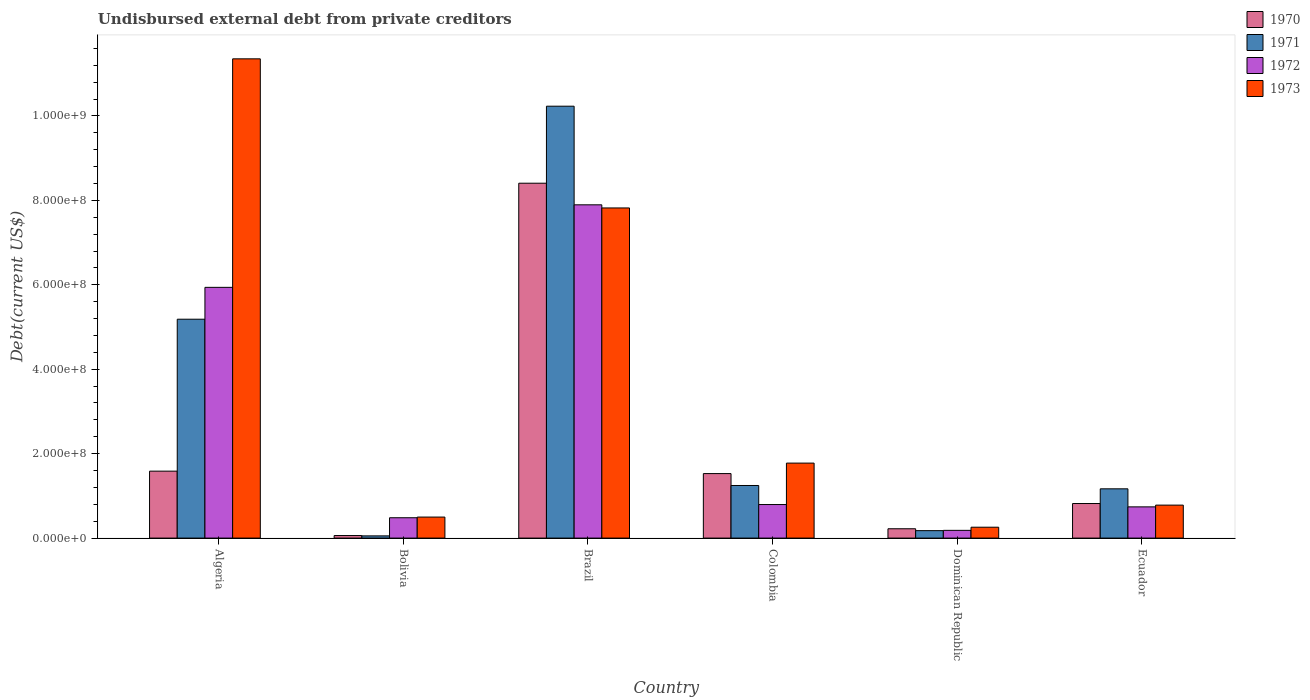How many different coloured bars are there?
Offer a terse response. 4. Are the number of bars on each tick of the X-axis equal?
Your response must be concise. Yes. What is the label of the 3rd group of bars from the left?
Keep it short and to the point. Brazil. In how many cases, is the number of bars for a given country not equal to the number of legend labels?
Give a very brief answer. 0. What is the total debt in 1973 in Algeria?
Provide a succinct answer. 1.14e+09. Across all countries, what is the maximum total debt in 1970?
Provide a succinct answer. 8.41e+08. Across all countries, what is the minimum total debt in 1970?
Your answer should be compact. 6.05e+06. In which country was the total debt in 1972 maximum?
Offer a terse response. Brazil. What is the total total debt in 1971 in the graph?
Give a very brief answer. 1.81e+09. What is the difference between the total debt in 1971 in Colombia and that in Dominican Republic?
Offer a very short reply. 1.07e+08. What is the difference between the total debt in 1973 in Algeria and the total debt in 1970 in Ecuador?
Ensure brevity in your answer.  1.05e+09. What is the average total debt in 1973 per country?
Ensure brevity in your answer.  3.75e+08. What is the difference between the total debt of/in 1973 and total debt of/in 1971 in Colombia?
Keep it short and to the point. 5.30e+07. What is the ratio of the total debt in 1972 in Algeria to that in Bolivia?
Make the answer very short. 12.32. Is the total debt in 1973 in Dominican Republic less than that in Ecuador?
Your response must be concise. Yes. What is the difference between the highest and the second highest total debt in 1973?
Your response must be concise. 9.58e+08. What is the difference between the highest and the lowest total debt in 1972?
Offer a very short reply. 7.71e+08. Is it the case that in every country, the sum of the total debt in 1972 and total debt in 1971 is greater than the sum of total debt in 1973 and total debt in 1970?
Ensure brevity in your answer.  No. What does the 4th bar from the right in Colombia represents?
Offer a very short reply. 1970. How many bars are there?
Ensure brevity in your answer.  24. Are all the bars in the graph horizontal?
Keep it short and to the point. No. Where does the legend appear in the graph?
Offer a terse response. Top right. How are the legend labels stacked?
Give a very brief answer. Vertical. What is the title of the graph?
Give a very brief answer. Undisbursed external debt from private creditors. What is the label or title of the Y-axis?
Give a very brief answer. Debt(current US$). What is the Debt(current US$) of 1970 in Algeria?
Provide a succinct answer. 1.59e+08. What is the Debt(current US$) of 1971 in Algeria?
Give a very brief answer. 5.18e+08. What is the Debt(current US$) of 1972 in Algeria?
Provide a succinct answer. 5.94e+08. What is the Debt(current US$) in 1973 in Algeria?
Offer a terse response. 1.14e+09. What is the Debt(current US$) in 1970 in Bolivia?
Your answer should be compact. 6.05e+06. What is the Debt(current US$) in 1971 in Bolivia?
Ensure brevity in your answer.  5.25e+06. What is the Debt(current US$) of 1972 in Bolivia?
Give a very brief answer. 4.82e+07. What is the Debt(current US$) of 1973 in Bolivia?
Give a very brief answer. 4.98e+07. What is the Debt(current US$) in 1970 in Brazil?
Make the answer very short. 8.41e+08. What is the Debt(current US$) of 1971 in Brazil?
Offer a very short reply. 1.02e+09. What is the Debt(current US$) in 1972 in Brazil?
Keep it short and to the point. 7.89e+08. What is the Debt(current US$) in 1973 in Brazil?
Offer a terse response. 7.82e+08. What is the Debt(current US$) of 1970 in Colombia?
Keep it short and to the point. 1.53e+08. What is the Debt(current US$) in 1971 in Colombia?
Your response must be concise. 1.25e+08. What is the Debt(current US$) of 1972 in Colombia?
Keep it short and to the point. 7.95e+07. What is the Debt(current US$) in 1973 in Colombia?
Ensure brevity in your answer.  1.78e+08. What is the Debt(current US$) in 1970 in Dominican Republic?
Keep it short and to the point. 2.21e+07. What is the Debt(current US$) of 1971 in Dominican Republic?
Your answer should be very brief. 1.76e+07. What is the Debt(current US$) in 1972 in Dominican Republic?
Keep it short and to the point. 1.83e+07. What is the Debt(current US$) of 1973 in Dominican Republic?
Give a very brief answer. 2.58e+07. What is the Debt(current US$) in 1970 in Ecuador?
Offer a terse response. 8.19e+07. What is the Debt(current US$) in 1971 in Ecuador?
Your answer should be compact. 1.17e+08. What is the Debt(current US$) in 1972 in Ecuador?
Provide a succinct answer. 7.40e+07. What is the Debt(current US$) in 1973 in Ecuador?
Offer a very short reply. 7.81e+07. Across all countries, what is the maximum Debt(current US$) in 1970?
Your answer should be very brief. 8.41e+08. Across all countries, what is the maximum Debt(current US$) in 1971?
Your answer should be very brief. 1.02e+09. Across all countries, what is the maximum Debt(current US$) of 1972?
Offer a very short reply. 7.89e+08. Across all countries, what is the maximum Debt(current US$) in 1973?
Provide a short and direct response. 1.14e+09. Across all countries, what is the minimum Debt(current US$) of 1970?
Your answer should be very brief. 6.05e+06. Across all countries, what is the minimum Debt(current US$) in 1971?
Make the answer very short. 5.25e+06. Across all countries, what is the minimum Debt(current US$) in 1972?
Give a very brief answer. 1.83e+07. Across all countries, what is the minimum Debt(current US$) of 1973?
Make the answer very short. 2.58e+07. What is the total Debt(current US$) in 1970 in the graph?
Keep it short and to the point. 1.26e+09. What is the total Debt(current US$) of 1971 in the graph?
Offer a terse response. 1.81e+09. What is the total Debt(current US$) of 1972 in the graph?
Your answer should be very brief. 1.60e+09. What is the total Debt(current US$) in 1973 in the graph?
Your answer should be very brief. 2.25e+09. What is the difference between the Debt(current US$) of 1970 in Algeria and that in Bolivia?
Your answer should be compact. 1.53e+08. What is the difference between the Debt(current US$) of 1971 in Algeria and that in Bolivia?
Offer a terse response. 5.13e+08. What is the difference between the Debt(current US$) in 1972 in Algeria and that in Bolivia?
Make the answer very short. 5.46e+08. What is the difference between the Debt(current US$) of 1973 in Algeria and that in Bolivia?
Make the answer very short. 1.09e+09. What is the difference between the Debt(current US$) in 1970 in Algeria and that in Brazil?
Ensure brevity in your answer.  -6.82e+08. What is the difference between the Debt(current US$) of 1971 in Algeria and that in Brazil?
Offer a terse response. -5.05e+08. What is the difference between the Debt(current US$) of 1972 in Algeria and that in Brazil?
Keep it short and to the point. -1.95e+08. What is the difference between the Debt(current US$) in 1973 in Algeria and that in Brazil?
Give a very brief answer. 3.53e+08. What is the difference between the Debt(current US$) of 1970 in Algeria and that in Colombia?
Offer a terse response. 5.77e+06. What is the difference between the Debt(current US$) of 1971 in Algeria and that in Colombia?
Offer a terse response. 3.94e+08. What is the difference between the Debt(current US$) in 1972 in Algeria and that in Colombia?
Ensure brevity in your answer.  5.14e+08. What is the difference between the Debt(current US$) in 1973 in Algeria and that in Colombia?
Your answer should be very brief. 9.58e+08. What is the difference between the Debt(current US$) in 1970 in Algeria and that in Dominican Republic?
Ensure brevity in your answer.  1.36e+08. What is the difference between the Debt(current US$) in 1971 in Algeria and that in Dominican Republic?
Your answer should be compact. 5.01e+08. What is the difference between the Debt(current US$) of 1972 in Algeria and that in Dominican Republic?
Offer a terse response. 5.76e+08. What is the difference between the Debt(current US$) of 1973 in Algeria and that in Dominican Republic?
Your response must be concise. 1.11e+09. What is the difference between the Debt(current US$) in 1970 in Algeria and that in Ecuador?
Provide a succinct answer. 7.67e+07. What is the difference between the Debt(current US$) in 1971 in Algeria and that in Ecuador?
Offer a very short reply. 4.02e+08. What is the difference between the Debt(current US$) in 1972 in Algeria and that in Ecuador?
Offer a very short reply. 5.20e+08. What is the difference between the Debt(current US$) of 1973 in Algeria and that in Ecuador?
Provide a short and direct response. 1.06e+09. What is the difference between the Debt(current US$) of 1970 in Bolivia and that in Brazil?
Provide a succinct answer. -8.35e+08. What is the difference between the Debt(current US$) in 1971 in Bolivia and that in Brazil?
Keep it short and to the point. -1.02e+09. What is the difference between the Debt(current US$) in 1972 in Bolivia and that in Brazil?
Offer a very short reply. -7.41e+08. What is the difference between the Debt(current US$) in 1973 in Bolivia and that in Brazil?
Provide a succinct answer. -7.32e+08. What is the difference between the Debt(current US$) of 1970 in Bolivia and that in Colombia?
Provide a succinct answer. -1.47e+08. What is the difference between the Debt(current US$) of 1971 in Bolivia and that in Colombia?
Provide a short and direct response. -1.19e+08. What is the difference between the Debt(current US$) in 1972 in Bolivia and that in Colombia?
Offer a very short reply. -3.13e+07. What is the difference between the Debt(current US$) in 1973 in Bolivia and that in Colombia?
Give a very brief answer. -1.28e+08. What is the difference between the Debt(current US$) of 1970 in Bolivia and that in Dominican Republic?
Provide a succinct answer. -1.60e+07. What is the difference between the Debt(current US$) of 1971 in Bolivia and that in Dominican Republic?
Offer a very short reply. -1.24e+07. What is the difference between the Debt(current US$) in 1972 in Bolivia and that in Dominican Republic?
Your answer should be compact. 2.99e+07. What is the difference between the Debt(current US$) of 1973 in Bolivia and that in Dominican Republic?
Provide a succinct answer. 2.40e+07. What is the difference between the Debt(current US$) of 1970 in Bolivia and that in Ecuador?
Make the answer very short. -7.58e+07. What is the difference between the Debt(current US$) in 1971 in Bolivia and that in Ecuador?
Provide a short and direct response. -1.11e+08. What is the difference between the Debt(current US$) of 1972 in Bolivia and that in Ecuador?
Your answer should be compact. -2.58e+07. What is the difference between the Debt(current US$) in 1973 in Bolivia and that in Ecuador?
Offer a terse response. -2.83e+07. What is the difference between the Debt(current US$) of 1970 in Brazil and that in Colombia?
Give a very brief answer. 6.88e+08. What is the difference between the Debt(current US$) in 1971 in Brazil and that in Colombia?
Give a very brief answer. 8.98e+08. What is the difference between the Debt(current US$) in 1972 in Brazil and that in Colombia?
Your answer should be very brief. 7.10e+08. What is the difference between the Debt(current US$) of 1973 in Brazil and that in Colombia?
Offer a very short reply. 6.04e+08. What is the difference between the Debt(current US$) of 1970 in Brazil and that in Dominican Republic?
Your answer should be very brief. 8.19e+08. What is the difference between the Debt(current US$) of 1971 in Brazil and that in Dominican Republic?
Offer a very short reply. 1.01e+09. What is the difference between the Debt(current US$) in 1972 in Brazil and that in Dominican Republic?
Make the answer very short. 7.71e+08. What is the difference between the Debt(current US$) in 1973 in Brazil and that in Dominican Republic?
Provide a succinct answer. 7.56e+08. What is the difference between the Debt(current US$) in 1970 in Brazil and that in Ecuador?
Provide a short and direct response. 7.59e+08. What is the difference between the Debt(current US$) in 1971 in Brazil and that in Ecuador?
Your answer should be compact. 9.06e+08. What is the difference between the Debt(current US$) in 1972 in Brazil and that in Ecuador?
Provide a short and direct response. 7.15e+08. What is the difference between the Debt(current US$) of 1973 in Brazil and that in Ecuador?
Provide a succinct answer. 7.04e+08. What is the difference between the Debt(current US$) of 1970 in Colombia and that in Dominican Republic?
Make the answer very short. 1.31e+08. What is the difference between the Debt(current US$) of 1971 in Colombia and that in Dominican Republic?
Make the answer very short. 1.07e+08. What is the difference between the Debt(current US$) of 1972 in Colombia and that in Dominican Republic?
Offer a terse response. 6.12e+07. What is the difference between the Debt(current US$) of 1973 in Colombia and that in Dominican Republic?
Your response must be concise. 1.52e+08. What is the difference between the Debt(current US$) in 1970 in Colombia and that in Ecuador?
Your response must be concise. 7.09e+07. What is the difference between the Debt(current US$) in 1971 in Colombia and that in Ecuador?
Offer a very short reply. 7.88e+06. What is the difference between the Debt(current US$) in 1972 in Colombia and that in Ecuador?
Your answer should be very brief. 5.49e+06. What is the difference between the Debt(current US$) of 1973 in Colombia and that in Ecuador?
Offer a very short reply. 9.95e+07. What is the difference between the Debt(current US$) of 1970 in Dominican Republic and that in Ecuador?
Offer a very short reply. -5.98e+07. What is the difference between the Debt(current US$) of 1971 in Dominican Republic and that in Ecuador?
Your answer should be very brief. -9.91e+07. What is the difference between the Debt(current US$) in 1972 in Dominican Republic and that in Ecuador?
Offer a terse response. -5.57e+07. What is the difference between the Debt(current US$) of 1973 in Dominican Republic and that in Ecuador?
Offer a terse response. -5.23e+07. What is the difference between the Debt(current US$) of 1970 in Algeria and the Debt(current US$) of 1971 in Bolivia?
Your answer should be very brief. 1.53e+08. What is the difference between the Debt(current US$) of 1970 in Algeria and the Debt(current US$) of 1972 in Bolivia?
Provide a short and direct response. 1.10e+08. What is the difference between the Debt(current US$) of 1970 in Algeria and the Debt(current US$) of 1973 in Bolivia?
Offer a terse response. 1.09e+08. What is the difference between the Debt(current US$) of 1971 in Algeria and the Debt(current US$) of 1972 in Bolivia?
Your response must be concise. 4.70e+08. What is the difference between the Debt(current US$) of 1971 in Algeria and the Debt(current US$) of 1973 in Bolivia?
Your answer should be compact. 4.69e+08. What is the difference between the Debt(current US$) of 1972 in Algeria and the Debt(current US$) of 1973 in Bolivia?
Your answer should be very brief. 5.44e+08. What is the difference between the Debt(current US$) of 1970 in Algeria and the Debt(current US$) of 1971 in Brazil?
Make the answer very short. -8.64e+08. What is the difference between the Debt(current US$) in 1970 in Algeria and the Debt(current US$) in 1972 in Brazil?
Your answer should be compact. -6.31e+08. What is the difference between the Debt(current US$) of 1970 in Algeria and the Debt(current US$) of 1973 in Brazil?
Your answer should be compact. -6.23e+08. What is the difference between the Debt(current US$) of 1971 in Algeria and the Debt(current US$) of 1972 in Brazil?
Your answer should be compact. -2.71e+08. What is the difference between the Debt(current US$) of 1971 in Algeria and the Debt(current US$) of 1973 in Brazil?
Your response must be concise. -2.64e+08. What is the difference between the Debt(current US$) of 1972 in Algeria and the Debt(current US$) of 1973 in Brazil?
Keep it short and to the point. -1.88e+08. What is the difference between the Debt(current US$) in 1970 in Algeria and the Debt(current US$) in 1971 in Colombia?
Your answer should be compact. 3.40e+07. What is the difference between the Debt(current US$) of 1970 in Algeria and the Debt(current US$) of 1972 in Colombia?
Ensure brevity in your answer.  7.91e+07. What is the difference between the Debt(current US$) in 1970 in Algeria and the Debt(current US$) in 1973 in Colombia?
Ensure brevity in your answer.  -1.90e+07. What is the difference between the Debt(current US$) of 1971 in Algeria and the Debt(current US$) of 1972 in Colombia?
Offer a terse response. 4.39e+08. What is the difference between the Debt(current US$) in 1971 in Algeria and the Debt(current US$) in 1973 in Colombia?
Provide a succinct answer. 3.41e+08. What is the difference between the Debt(current US$) in 1972 in Algeria and the Debt(current US$) in 1973 in Colombia?
Your answer should be very brief. 4.16e+08. What is the difference between the Debt(current US$) in 1970 in Algeria and the Debt(current US$) in 1971 in Dominican Republic?
Provide a short and direct response. 1.41e+08. What is the difference between the Debt(current US$) in 1970 in Algeria and the Debt(current US$) in 1972 in Dominican Republic?
Offer a terse response. 1.40e+08. What is the difference between the Debt(current US$) in 1970 in Algeria and the Debt(current US$) in 1973 in Dominican Republic?
Make the answer very short. 1.33e+08. What is the difference between the Debt(current US$) in 1971 in Algeria and the Debt(current US$) in 1972 in Dominican Republic?
Your response must be concise. 5.00e+08. What is the difference between the Debt(current US$) in 1971 in Algeria and the Debt(current US$) in 1973 in Dominican Republic?
Ensure brevity in your answer.  4.93e+08. What is the difference between the Debt(current US$) of 1972 in Algeria and the Debt(current US$) of 1973 in Dominican Republic?
Your answer should be very brief. 5.68e+08. What is the difference between the Debt(current US$) of 1970 in Algeria and the Debt(current US$) of 1971 in Ecuador?
Offer a terse response. 4.18e+07. What is the difference between the Debt(current US$) of 1970 in Algeria and the Debt(current US$) of 1972 in Ecuador?
Your answer should be compact. 8.46e+07. What is the difference between the Debt(current US$) in 1970 in Algeria and the Debt(current US$) in 1973 in Ecuador?
Your answer should be very brief. 8.05e+07. What is the difference between the Debt(current US$) in 1971 in Algeria and the Debt(current US$) in 1972 in Ecuador?
Offer a terse response. 4.44e+08. What is the difference between the Debt(current US$) of 1971 in Algeria and the Debt(current US$) of 1973 in Ecuador?
Provide a succinct answer. 4.40e+08. What is the difference between the Debt(current US$) of 1972 in Algeria and the Debt(current US$) of 1973 in Ecuador?
Provide a short and direct response. 5.16e+08. What is the difference between the Debt(current US$) in 1970 in Bolivia and the Debt(current US$) in 1971 in Brazil?
Your answer should be compact. -1.02e+09. What is the difference between the Debt(current US$) in 1970 in Bolivia and the Debt(current US$) in 1972 in Brazil?
Keep it short and to the point. -7.83e+08. What is the difference between the Debt(current US$) in 1970 in Bolivia and the Debt(current US$) in 1973 in Brazil?
Offer a very short reply. -7.76e+08. What is the difference between the Debt(current US$) of 1971 in Bolivia and the Debt(current US$) of 1972 in Brazil?
Offer a terse response. -7.84e+08. What is the difference between the Debt(current US$) of 1971 in Bolivia and the Debt(current US$) of 1973 in Brazil?
Offer a very short reply. -7.77e+08. What is the difference between the Debt(current US$) of 1972 in Bolivia and the Debt(current US$) of 1973 in Brazil?
Your response must be concise. -7.34e+08. What is the difference between the Debt(current US$) in 1970 in Bolivia and the Debt(current US$) in 1971 in Colombia?
Provide a short and direct response. -1.19e+08. What is the difference between the Debt(current US$) of 1970 in Bolivia and the Debt(current US$) of 1972 in Colombia?
Offer a terse response. -7.34e+07. What is the difference between the Debt(current US$) in 1970 in Bolivia and the Debt(current US$) in 1973 in Colombia?
Provide a succinct answer. -1.72e+08. What is the difference between the Debt(current US$) of 1971 in Bolivia and the Debt(current US$) of 1972 in Colombia?
Offer a very short reply. -7.42e+07. What is the difference between the Debt(current US$) of 1971 in Bolivia and the Debt(current US$) of 1973 in Colombia?
Your answer should be compact. -1.72e+08. What is the difference between the Debt(current US$) of 1972 in Bolivia and the Debt(current US$) of 1973 in Colombia?
Your answer should be compact. -1.29e+08. What is the difference between the Debt(current US$) of 1970 in Bolivia and the Debt(current US$) of 1971 in Dominican Republic?
Ensure brevity in your answer.  -1.16e+07. What is the difference between the Debt(current US$) of 1970 in Bolivia and the Debt(current US$) of 1972 in Dominican Republic?
Provide a short and direct response. -1.23e+07. What is the difference between the Debt(current US$) of 1970 in Bolivia and the Debt(current US$) of 1973 in Dominican Republic?
Your answer should be compact. -1.97e+07. What is the difference between the Debt(current US$) of 1971 in Bolivia and the Debt(current US$) of 1972 in Dominican Republic?
Give a very brief answer. -1.31e+07. What is the difference between the Debt(current US$) of 1971 in Bolivia and the Debt(current US$) of 1973 in Dominican Republic?
Ensure brevity in your answer.  -2.05e+07. What is the difference between the Debt(current US$) in 1972 in Bolivia and the Debt(current US$) in 1973 in Dominican Republic?
Your response must be concise. 2.24e+07. What is the difference between the Debt(current US$) in 1970 in Bolivia and the Debt(current US$) in 1971 in Ecuador?
Your answer should be compact. -1.11e+08. What is the difference between the Debt(current US$) in 1970 in Bolivia and the Debt(current US$) in 1972 in Ecuador?
Keep it short and to the point. -6.79e+07. What is the difference between the Debt(current US$) of 1970 in Bolivia and the Debt(current US$) of 1973 in Ecuador?
Your answer should be compact. -7.21e+07. What is the difference between the Debt(current US$) in 1971 in Bolivia and the Debt(current US$) in 1972 in Ecuador?
Your response must be concise. -6.87e+07. What is the difference between the Debt(current US$) of 1971 in Bolivia and the Debt(current US$) of 1973 in Ecuador?
Keep it short and to the point. -7.29e+07. What is the difference between the Debt(current US$) in 1972 in Bolivia and the Debt(current US$) in 1973 in Ecuador?
Offer a very short reply. -2.99e+07. What is the difference between the Debt(current US$) in 1970 in Brazil and the Debt(current US$) in 1971 in Colombia?
Your answer should be very brief. 7.16e+08. What is the difference between the Debt(current US$) in 1970 in Brazil and the Debt(current US$) in 1972 in Colombia?
Your response must be concise. 7.61e+08. What is the difference between the Debt(current US$) of 1970 in Brazil and the Debt(current US$) of 1973 in Colombia?
Ensure brevity in your answer.  6.63e+08. What is the difference between the Debt(current US$) of 1971 in Brazil and the Debt(current US$) of 1972 in Colombia?
Keep it short and to the point. 9.44e+08. What is the difference between the Debt(current US$) of 1971 in Brazil and the Debt(current US$) of 1973 in Colombia?
Your answer should be compact. 8.45e+08. What is the difference between the Debt(current US$) in 1972 in Brazil and the Debt(current US$) in 1973 in Colombia?
Provide a short and direct response. 6.12e+08. What is the difference between the Debt(current US$) in 1970 in Brazil and the Debt(current US$) in 1971 in Dominican Republic?
Offer a very short reply. 8.23e+08. What is the difference between the Debt(current US$) of 1970 in Brazil and the Debt(current US$) of 1972 in Dominican Republic?
Offer a terse response. 8.22e+08. What is the difference between the Debt(current US$) of 1970 in Brazil and the Debt(current US$) of 1973 in Dominican Republic?
Your answer should be very brief. 8.15e+08. What is the difference between the Debt(current US$) of 1971 in Brazil and the Debt(current US$) of 1972 in Dominican Republic?
Give a very brief answer. 1.00e+09. What is the difference between the Debt(current US$) of 1971 in Brazil and the Debt(current US$) of 1973 in Dominican Republic?
Your answer should be very brief. 9.97e+08. What is the difference between the Debt(current US$) of 1972 in Brazil and the Debt(current US$) of 1973 in Dominican Republic?
Your answer should be compact. 7.64e+08. What is the difference between the Debt(current US$) of 1970 in Brazil and the Debt(current US$) of 1971 in Ecuador?
Keep it short and to the point. 7.24e+08. What is the difference between the Debt(current US$) in 1970 in Brazil and the Debt(current US$) in 1972 in Ecuador?
Offer a terse response. 7.67e+08. What is the difference between the Debt(current US$) of 1970 in Brazil and the Debt(current US$) of 1973 in Ecuador?
Ensure brevity in your answer.  7.63e+08. What is the difference between the Debt(current US$) of 1971 in Brazil and the Debt(current US$) of 1972 in Ecuador?
Provide a succinct answer. 9.49e+08. What is the difference between the Debt(current US$) in 1971 in Brazil and the Debt(current US$) in 1973 in Ecuador?
Your response must be concise. 9.45e+08. What is the difference between the Debt(current US$) of 1972 in Brazil and the Debt(current US$) of 1973 in Ecuador?
Make the answer very short. 7.11e+08. What is the difference between the Debt(current US$) in 1970 in Colombia and the Debt(current US$) in 1971 in Dominican Republic?
Your answer should be compact. 1.35e+08. What is the difference between the Debt(current US$) in 1970 in Colombia and the Debt(current US$) in 1972 in Dominican Republic?
Keep it short and to the point. 1.34e+08. What is the difference between the Debt(current US$) of 1970 in Colombia and the Debt(current US$) of 1973 in Dominican Republic?
Your answer should be compact. 1.27e+08. What is the difference between the Debt(current US$) in 1971 in Colombia and the Debt(current US$) in 1972 in Dominican Republic?
Provide a succinct answer. 1.06e+08. What is the difference between the Debt(current US$) in 1971 in Colombia and the Debt(current US$) in 1973 in Dominican Republic?
Your answer should be compact. 9.88e+07. What is the difference between the Debt(current US$) of 1972 in Colombia and the Debt(current US$) of 1973 in Dominican Republic?
Make the answer very short. 5.37e+07. What is the difference between the Debt(current US$) of 1970 in Colombia and the Debt(current US$) of 1971 in Ecuador?
Keep it short and to the point. 3.61e+07. What is the difference between the Debt(current US$) in 1970 in Colombia and the Debt(current US$) in 1972 in Ecuador?
Give a very brief answer. 7.88e+07. What is the difference between the Debt(current US$) of 1970 in Colombia and the Debt(current US$) of 1973 in Ecuador?
Offer a very short reply. 7.47e+07. What is the difference between the Debt(current US$) in 1971 in Colombia and the Debt(current US$) in 1972 in Ecuador?
Offer a very short reply. 5.06e+07. What is the difference between the Debt(current US$) of 1971 in Colombia and the Debt(current US$) of 1973 in Ecuador?
Make the answer very short. 4.65e+07. What is the difference between the Debt(current US$) of 1972 in Colombia and the Debt(current US$) of 1973 in Ecuador?
Ensure brevity in your answer.  1.36e+06. What is the difference between the Debt(current US$) in 1970 in Dominican Republic and the Debt(current US$) in 1971 in Ecuador?
Your answer should be very brief. -9.46e+07. What is the difference between the Debt(current US$) of 1970 in Dominican Republic and the Debt(current US$) of 1972 in Ecuador?
Offer a very short reply. -5.19e+07. What is the difference between the Debt(current US$) in 1970 in Dominican Republic and the Debt(current US$) in 1973 in Ecuador?
Give a very brief answer. -5.60e+07. What is the difference between the Debt(current US$) of 1971 in Dominican Republic and the Debt(current US$) of 1972 in Ecuador?
Keep it short and to the point. -5.63e+07. What is the difference between the Debt(current US$) in 1971 in Dominican Republic and the Debt(current US$) in 1973 in Ecuador?
Your response must be concise. -6.05e+07. What is the difference between the Debt(current US$) in 1972 in Dominican Republic and the Debt(current US$) in 1973 in Ecuador?
Provide a succinct answer. -5.98e+07. What is the average Debt(current US$) of 1970 per country?
Your answer should be very brief. 2.10e+08. What is the average Debt(current US$) of 1971 per country?
Make the answer very short. 3.01e+08. What is the average Debt(current US$) of 1972 per country?
Your response must be concise. 2.67e+08. What is the average Debt(current US$) in 1973 per country?
Keep it short and to the point. 3.75e+08. What is the difference between the Debt(current US$) in 1970 and Debt(current US$) in 1971 in Algeria?
Keep it short and to the point. -3.60e+08. What is the difference between the Debt(current US$) in 1970 and Debt(current US$) in 1972 in Algeria?
Make the answer very short. -4.35e+08. What is the difference between the Debt(current US$) of 1970 and Debt(current US$) of 1973 in Algeria?
Your answer should be compact. -9.77e+08. What is the difference between the Debt(current US$) in 1971 and Debt(current US$) in 1972 in Algeria?
Offer a terse response. -7.55e+07. What is the difference between the Debt(current US$) in 1971 and Debt(current US$) in 1973 in Algeria?
Provide a short and direct response. -6.17e+08. What is the difference between the Debt(current US$) in 1972 and Debt(current US$) in 1973 in Algeria?
Ensure brevity in your answer.  -5.41e+08. What is the difference between the Debt(current US$) of 1970 and Debt(current US$) of 1971 in Bolivia?
Ensure brevity in your answer.  8.02e+05. What is the difference between the Debt(current US$) of 1970 and Debt(current US$) of 1972 in Bolivia?
Offer a very short reply. -4.22e+07. What is the difference between the Debt(current US$) in 1970 and Debt(current US$) in 1973 in Bolivia?
Give a very brief answer. -4.37e+07. What is the difference between the Debt(current US$) of 1971 and Debt(current US$) of 1972 in Bolivia?
Ensure brevity in your answer.  -4.30e+07. What is the difference between the Debt(current US$) in 1971 and Debt(current US$) in 1973 in Bolivia?
Provide a short and direct response. -4.45e+07. What is the difference between the Debt(current US$) in 1972 and Debt(current US$) in 1973 in Bolivia?
Offer a very short reply. -1.58e+06. What is the difference between the Debt(current US$) of 1970 and Debt(current US$) of 1971 in Brazil?
Offer a terse response. -1.82e+08. What is the difference between the Debt(current US$) in 1970 and Debt(current US$) in 1972 in Brazil?
Give a very brief answer. 5.12e+07. What is the difference between the Debt(current US$) in 1970 and Debt(current US$) in 1973 in Brazil?
Provide a succinct answer. 5.86e+07. What is the difference between the Debt(current US$) in 1971 and Debt(current US$) in 1972 in Brazil?
Make the answer very short. 2.34e+08. What is the difference between the Debt(current US$) of 1971 and Debt(current US$) of 1973 in Brazil?
Give a very brief answer. 2.41e+08. What is the difference between the Debt(current US$) in 1972 and Debt(current US$) in 1973 in Brazil?
Your answer should be very brief. 7.41e+06. What is the difference between the Debt(current US$) of 1970 and Debt(current US$) of 1971 in Colombia?
Your answer should be compact. 2.82e+07. What is the difference between the Debt(current US$) of 1970 and Debt(current US$) of 1972 in Colombia?
Your answer should be very brief. 7.33e+07. What is the difference between the Debt(current US$) of 1970 and Debt(current US$) of 1973 in Colombia?
Your response must be concise. -2.48e+07. What is the difference between the Debt(current US$) in 1971 and Debt(current US$) in 1972 in Colombia?
Make the answer very short. 4.51e+07. What is the difference between the Debt(current US$) in 1971 and Debt(current US$) in 1973 in Colombia?
Provide a succinct answer. -5.30e+07. What is the difference between the Debt(current US$) in 1972 and Debt(current US$) in 1973 in Colombia?
Give a very brief answer. -9.81e+07. What is the difference between the Debt(current US$) of 1970 and Debt(current US$) of 1971 in Dominican Republic?
Ensure brevity in your answer.  4.46e+06. What is the difference between the Debt(current US$) in 1970 and Debt(current US$) in 1972 in Dominican Republic?
Give a very brief answer. 3.78e+06. What is the difference between the Debt(current US$) of 1970 and Debt(current US$) of 1973 in Dominican Republic?
Offer a very short reply. -3.68e+06. What is the difference between the Debt(current US$) in 1971 and Debt(current US$) in 1972 in Dominican Republic?
Offer a very short reply. -6.84e+05. What is the difference between the Debt(current US$) in 1971 and Debt(current US$) in 1973 in Dominican Republic?
Provide a short and direct response. -8.14e+06. What is the difference between the Debt(current US$) of 1972 and Debt(current US$) of 1973 in Dominican Republic?
Make the answer very short. -7.46e+06. What is the difference between the Debt(current US$) of 1970 and Debt(current US$) of 1971 in Ecuador?
Offer a very short reply. -3.48e+07. What is the difference between the Debt(current US$) of 1970 and Debt(current US$) of 1972 in Ecuador?
Keep it short and to the point. 7.92e+06. What is the difference between the Debt(current US$) in 1970 and Debt(current US$) in 1973 in Ecuador?
Offer a terse response. 3.78e+06. What is the difference between the Debt(current US$) in 1971 and Debt(current US$) in 1972 in Ecuador?
Offer a terse response. 4.27e+07. What is the difference between the Debt(current US$) in 1971 and Debt(current US$) in 1973 in Ecuador?
Your response must be concise. 3.86e+07. What is the difference between the Debt(current US$) of 1972 and Debt(current US$) of 1973 in Ecuador?
Your response must be concise. -4.14e+06. What is the ratio of the Debt(current US$) in 1970 in Algeria to that in Bolivia?
Offer a very short reply. 26.22. What is the ratio of the Debt(current US$) of 1971 in Algeria to that in Bolivia?
Offer a terse response. 98.83. What is the ratio of the Debt(current US$) of 1972 in Algeria to that in Bolivia?
Provide a short and direct response. 12.32. What is the ratio of the Debt(current US$) in 1973 in Algeria to that in Bolivia?
Offer a very short reply. 22.8. What is the ratio of the Debt(current US$) in 1970 in Algeria to that in Brazil?
Your answer should be compact. 0.19. What is the ratio of the Debt(current US$) of 1971 in Algeria to that in Brazil?
Your answer should be compact. 0.51. What is the ratio of the Debt(current US$) of 1972 in Algeria to that in Brazil?
Your response must be concise. 0.75. What is the ratio of the Debt(current US$) of 1973 in Algeria to that in Brazil?
Your response must be concise. 1.45. What is the ratio of the Debt(current US$) in 1970 in Algeria to that in Colombia?
Offer a terse response. 1.04. What is the ratio of the Debt(current US$) of 1971 in Algeria to that in Colombia?
Offer a terse response. 4.16. What is the ratio of the Debt(current US$) in 1972 in Algeria to that in Colombia?
Your answer should be very brief. 7.47. What is the ratio of the Debt(current US$) of 1973 in Algeria to that in Colombia?
Ensure brevity in your answer.  6.39. What is the ratio of the Debt(current US$) of 1970 in Algeria to that in Dominican Republic?
Your answer should be compact. 7.18. What is the ratio of the Debt(current US$) of 1971 in Algeria to that in Dominican Republic?
Keep it short and to the point. 29.4. What is the ratio of the Debt(current US$) of 1972 in Algeria to that in Dominican Republic?
Ensure brevity in your answer.  32.43. What is the ratio of the Debt(current US$) of 1973 in Algeria to that in Dominican Republic?
Give a very brief answer. 44.05. What is the ratio of the Debt(current US$) in 1970 in Algeria to that in Ecuador?
Provide a succinct answer. 1.94. What is the ratio of the Debt(current US$) of 1971 in Algeria to that in Ecuador?
Keep it short and to the point. 4.44. What is the ratio of the Debt(current US$) in 1972 in Algeria to that in Ecuador?
Give a very brief answer. 8.03. What is the ratio of the Debt(current US$) of 1973 in Algeria to that in Ecuador?
Your response must be concise. 14.53. What is the ratio of the Debt(current US$) in 1970 in Bolivia to that in Brazil?
Give a very brief answer. 0.01. What is the ratio of the Debt(current US$) of 1971 in Bolivia to that in Brazil?
Provide a short and direct response. 0.01. What is the ratio of the Debt(current US$) in 1972 in Bolivia to that in Brazil?
Give a very brief answer. 0.06. What is the ratio of the Debt(current US$) in 1973 in Bolivia to that in Brazil?
Your response must be concise. 0.06. What is the ratio of the Debt(current US$) of 1970 in Bolivia to that in Colombia?
Offer a very short reply. 0.04. What is the ratio of the Debt(current US$) in 1971 in Bolivia to that in Colombia?
Offer a terse response. 0.04. What is the ratio of the Debt(current US$) in 1972 in Bolivia to that in Colombia?
Keep it short and to the point. 0.61. What is the ratio of the Debt(current US$) of 1973 in Bolivia to that in Colombia?
Offer a terse response. 0.28. What is the ratio of the Debt(current US$) of 1970 in Bolivia to that in Dominican Republic?
Ensure brevity in your answer.  0.27. What is the ratio of the Debt(current US$) of 1971 in Bolivia to that in Dominican Republic?
Offer a terse response. 0.3. What is the ratio of the Debt(current US$) in 1972 in Bolivia to that in Dominican Republic?
Your response must be concise. 2.63. What is the ratio of the Debt(current US$) of 1973 in Bolivia to that in Dominican Republic?
Your response must be concise. 1.93. What is the ratio of the Debt(current US$) of 1970 in Bolivia to that in Ecuador?
Provide a succinct answer. 0.07. What is the ratio of the Debt(current US$) in 1971 in Bolivia to that in Ecuador?
Make the answer very short. 0.04. What is the ratio of the Debt(current US$) of 1972 in Bolivia to that in Ecuador?
Ensure brevity in your answer.  0.65. What is the ratio of the Debt(current US$) in 1973 in Bolivia to that in Ecuador?
Keep it short and to the point. 0.64. What is the ratio of the Debt(current US$) in 1970 in Brazil to that in Colombia?
Offer a very short reply. 5.5. What is the ratio of the Debt(current US$) of 1971 in Brazil to that in Colombia?
Offer a very short reply. 8.21. What is the ratio of the Debt(current US$) in 1972 in Brazil to that in Colombia?
Give a very brief answer. 9.93. What is the ratio of the Debt(current US$) in 1973 in Brazil to that in Colombia?
Ensure brevity in your answer.  4.4. What is the ratio of the Debt(current US$) in 1970 in Brazil to that in Dominican Republic?
Your answer should be very brief. 38.04. What is the ratio of the Debt(current US$) of 1971 in Brazil to that in Dominican Republic?
Provide a succinct answer. 58.02. What is the ratio of the Debt(current US$) of 1972 in Brazil to that in Dominican Republic?
Your answer should be compact. 43.1. What is the ratio of the Debt(current US$) in 1973 in Brazil to that in Dominican Republic?
Give a very brief answer. 30.34. What is the ratio of the Debt(current US$) of 1970 in Brazil to that in Ecuador?
Give a very brief answer. 10.26. What is the ratio of the Debt(current US$) of 1971 in Brazil to that in Ecuador?
Keep it short and to the point. 8.76. What is the ratio of the Debt(current US$) in 1972 in Brazil to that in Ecuador?
Provide a short and direct response. 10.67. What is the ratio of the Debt(current US$) of 1973 in Brazil to that in Ecuador?
Ensure brevity in your answer.  10.01. What is the ratio of the Debt(current US$) in 1970 in Colombia to that in Dominican Republic?
Give a very brief answer. 6.92. What is the ratio of the Debt(current US$) in 1971 in Colombia to that in Dominican Republic?
Your answer should be compact. 7.07. What is the ratio of the Debt(current US$) in 1972 in Colombia to that in Dominican Republic?
Your answer should be very brief. 4.34. What is the ratio of the Debt(current US$) in 1973 in Colombia to that in Dominican Republic?
Provide a succinct answer. 6.89. What is the ratio of the Debt(current US$) in 1970 in Colombia to that in Ecuador?
Give a very brief answer. 1.87. What is the ratio of the Debt(current US$) in 1971 in Colombia to that in Ecuador?
Provide a short and direct response. 1.07. What is the ratio of the Debt(current US$) in 1972 in Colombia to that in Ecuador?
Your response must be concise. 1.07. What is the ratio of the Debt(current US$) of 1973 in Colombia to that in Ecuador?
Ensure brevity in your answer.  2.27. What is the ratio of the Debt(current US$) of 1970 in Dominican Republic to that in Ecuador?
Your answer should be compact. 0.27. What is the ratio of the Debt(current US$) of 1971 in Dominican Republic to that in Ecuador?
Provide a short and direct response. 0.15. What is the ratio of the Debt(current US$) of 1972 in Dominican Republic to that in Ecuador?
Make the answer very short. 0.25. What is the ratio of the Debt(current US$) in 1973 in Dominican Republic to that in Ecuador?
Your answer should be very brief. 0.33. What is the difference between the highest and the second highest Debt(current US$) in 1970?
Offer a very short reply. 6.82e+08. What is the difference between the highest and the second highest Debt(current US$) in 1971?
Keep it short and to the point. 5.05e+08. What is the difference between the highest and the second highest Debt(current US$) in 1972?
Offer a very short reply. 1.95e+08. What is the difference between the highest and the second highest Debt(current US$) of 1973?
Give a very brief answer. 3.53e+08. What is the difference between the highest and the lowest Debt(current US$) of 1970?
Offer a very short reply. 8.35e+08. What is the difference between the highest and the lowest Debt(current US$) in 1971?
Your response must be concise. 1.02e+09. What is the difference between the highest and the lowest Debt(current US$) of 1972?
Your answer should be compact. 7.71e+08. What is the difference between the highest and the lowest Debt(current US$) in 1973?
Provide a succinct answer. 1.11e+09. 